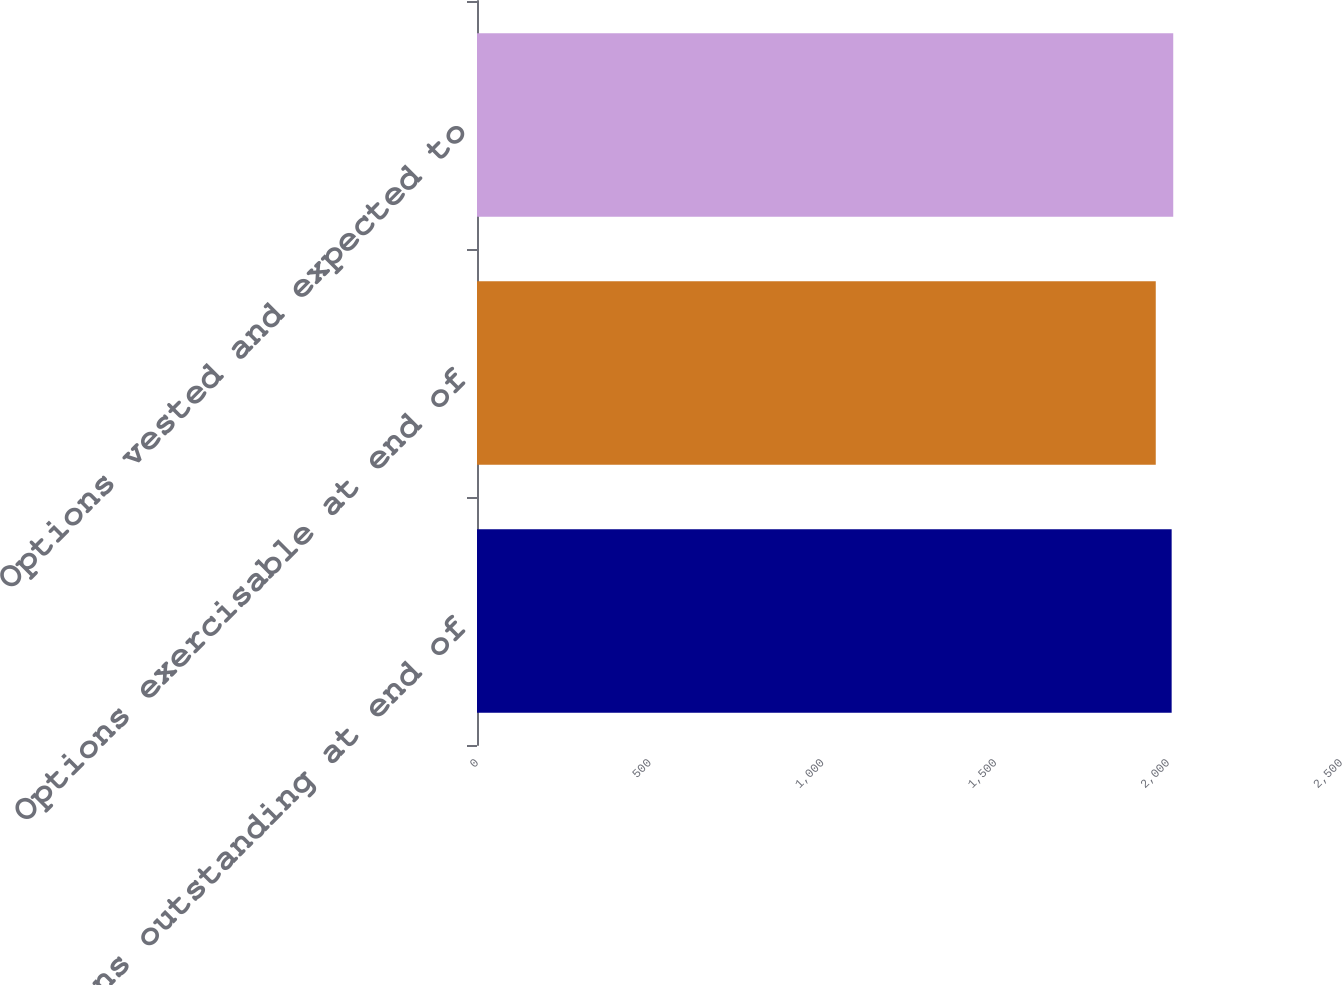Convert chart. <chart><loc_0><loc_0><loc_500><loc_500><bar_chart><fcel>Options outstanding at end of<fcel>Options exercisable at end of<fcel>Options vested and expected to<nl><fcel>2010<fcel>1964<fcel>2014.6<nl></chart> 